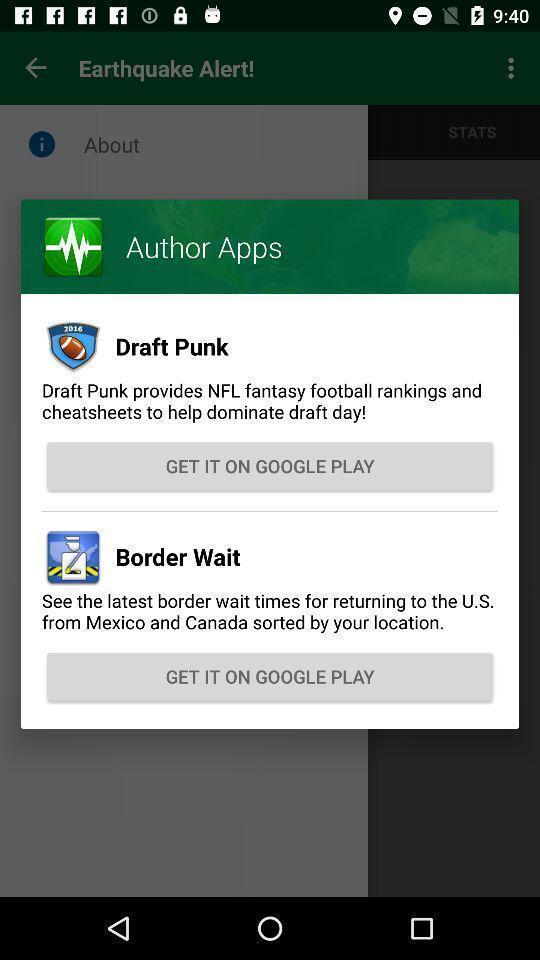What details can you identify in this image? Pop up window with apps. 